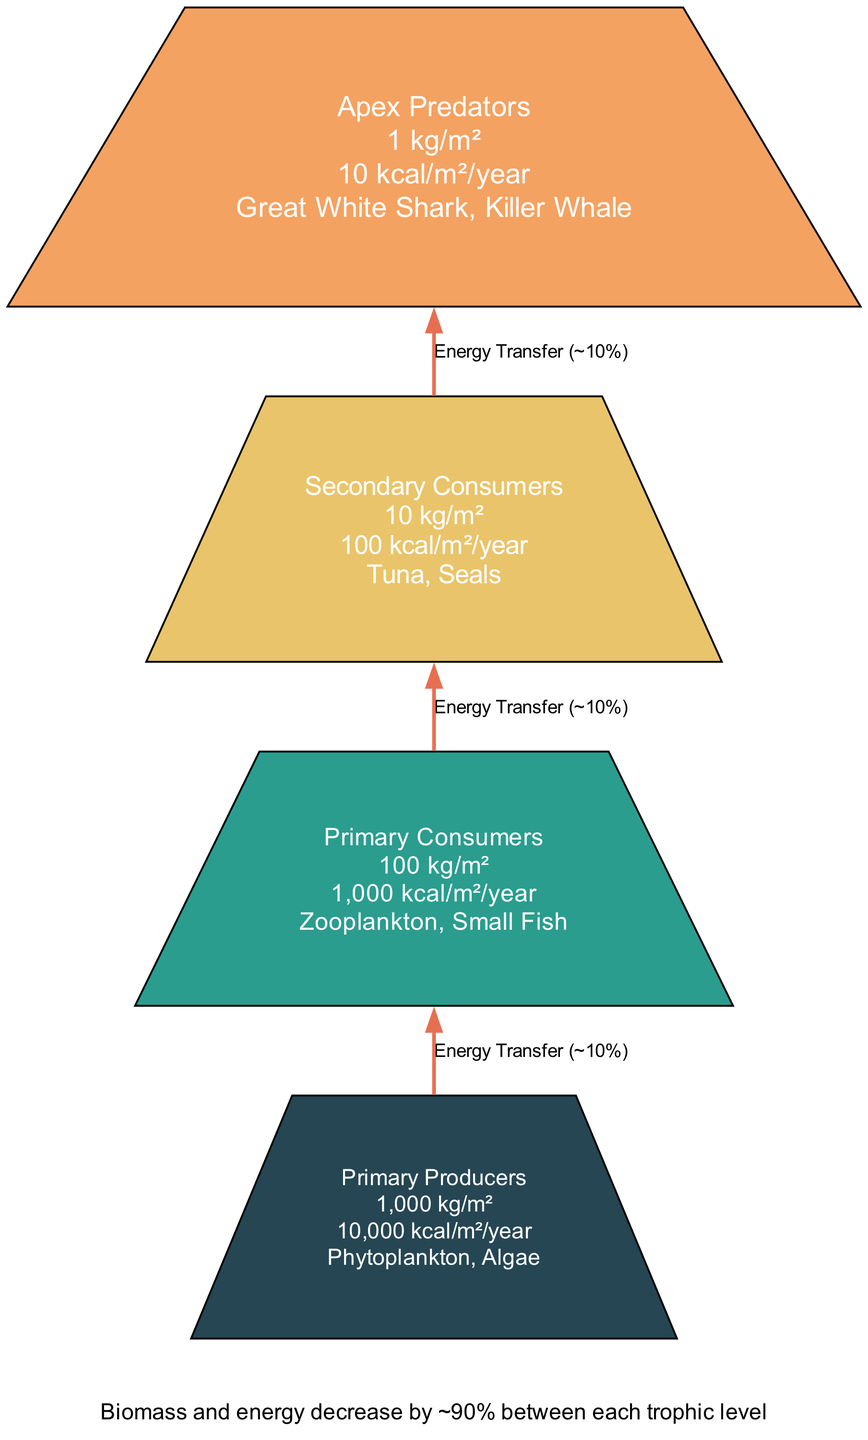What is the biomass of Apex Predators? According to the diagram, the biomass for Apex Predators is shown as "1 kg/m²" in the corresponding section.
Answer: 1 kg/m² How many examples are listed under Primary Producers? The section for Primary Producers lists two examples: "Phytoplankton" and "Algae". Thus, the count of examples is two.
Answer: 2 What percentage of energy is transferred from one trophic level to the next? The energy transfer label states "~10%" is the typical percentage of energy that moves upward between trophic levels, according to the diagram arrows.
Answer: ~10% What is the energy available at the Primary Consumers level? The diagram specifies that the energy available at the Primary Consumers level is "1,000 kcal/m²/year".
Answer: 1,000 kcal/m²/year Which layer has the highest biomass? The diagram indicates that Primary Producers possess the highest biomass, noted as "1,000 kg/m²", which is greater than that of any other layer.
Answer: Primary Producers How much biomass is lost when moving from Primary Producers to Primary Consumers? The biomass for Primary Producers is "1,000 kg/m²" and for Primary Consumers is "100 kg/m²", indicating a loss of "900 kg/m²" when transitioning between these two levels.
Answer: 900 kg/m² What is the total number of layers represented in the diagram? The diagram features four distinct layers (Apex Predators, Secondary Consumers, Primary Consumers, and Primary Producers), which is counted to determine the total.
Answer: 4 What is the energy value assigned to Secondary Consumers? The diagram shows that Secondary Consumers have an energy value of "100 kcal/m²/year". This figure corresponds to the entry next to the layer's label.
Answer: 100 kcal/m²/year What is the average biomass displayed across all levels? To find the average biomass, one can sum the biomass values (1 kg/m² + 10 kg/m² + 100 kg/m² + 1,000 kg/m²) which equals "1,111 kg/m²", and then divide by the number of layers (4), resulting in an average of "277.75 kg/m²". Therefore, the averaged biomass is closely approximated as 278 kg/m².
Answer: 278 kg/m² 